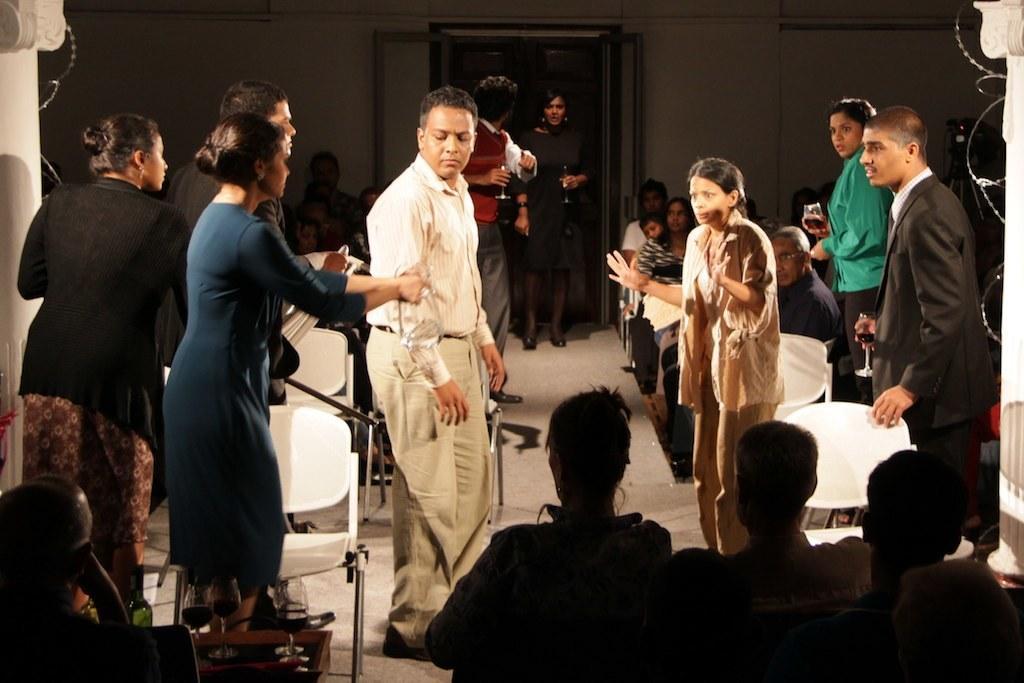Describe this image in one or two sentences. In this image we can see some people sitting on the chairs. A woman holding a man with her hands. Some people are holding glasses on the right side. On the left side we can see a person sitting on the chair. We can also see some glasses and a bottle on the table. 